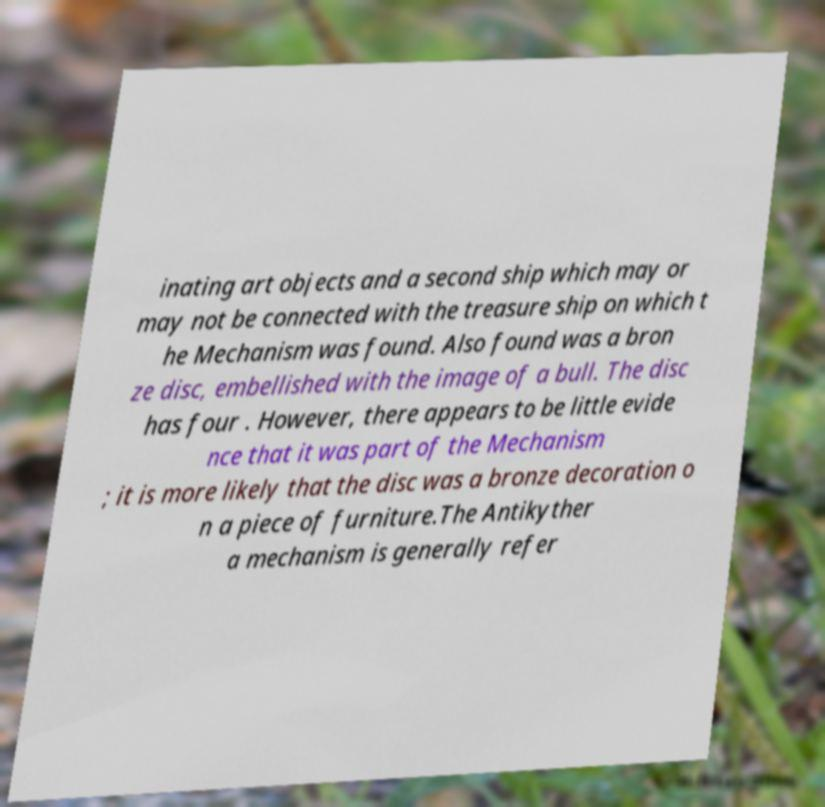Please read and relay the text visible in this image. What does it say? inating art objects and a second ship which may or may not be connected with the treasure ship on which t he Mechanism was found. Also found was a bron ze disc, embellished with the image of a bull. The disc has four . However, there appears to be little evide nce that it was part of the Mechanism ; it is more likely that the disc was a bronze decoration o n a piece of furniture.The Antikyther a mechanism is generally refer 